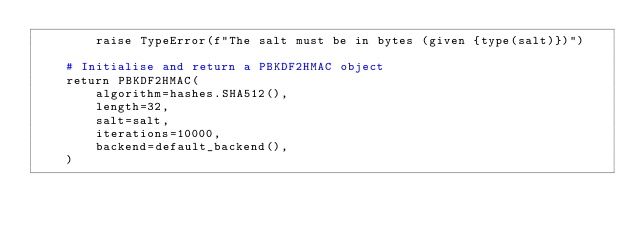<code> <loc_0><loc_0><loc_500><loc_500><_Python_>        raise TypeError(f"The salt must be in bytes (given {type(salt)})")

    # Initialise and return a PBKDF2HMAC object
    return PBKDF2HMAC(
        algorithm=hashes.SHA512(),
        length=32,
        salt=salt,
        iterations=10000,
        backend=default_backend(),
    )
</code> 